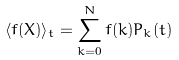<formula> <loc_0><loc_0><loc_500><loc_500>\langle f ( X ) \rangle _ { t } = \sum _ { k = 0 } ^ { N } f ( k ) P _ { k } ( t )</formula> 